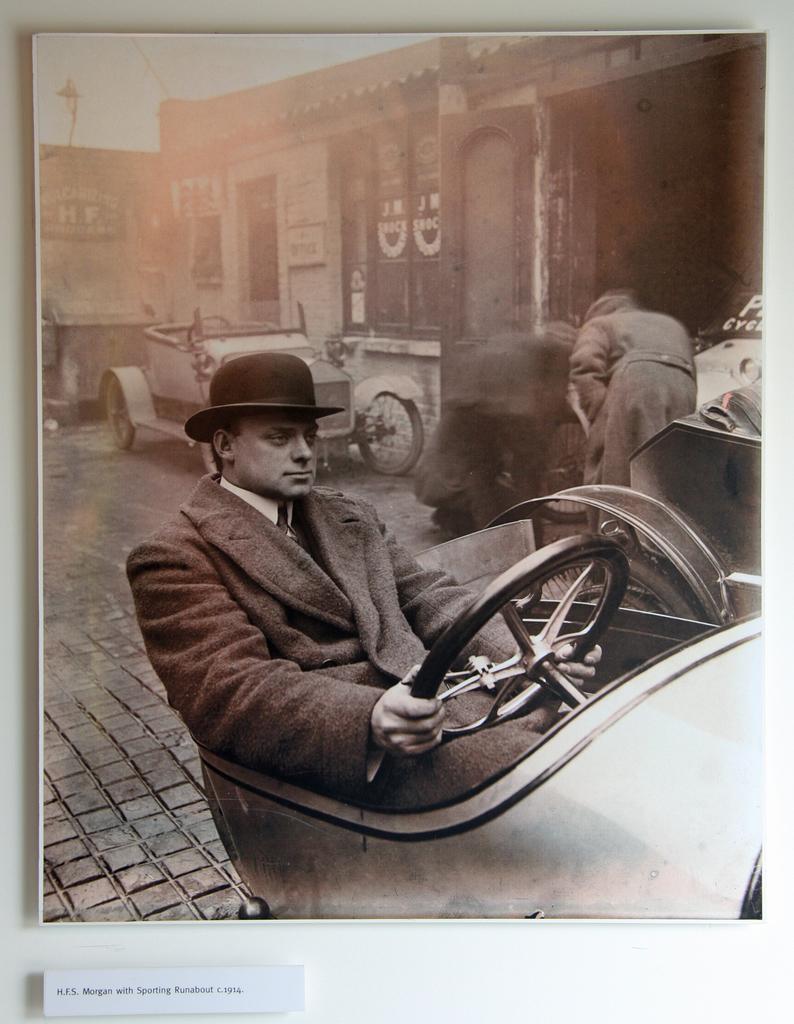Can you describe this image briefly? In this picture we can see a man driving a vehicle, he wore a cap, in the background we can see a house, we can see a vehicle in front of the house. 